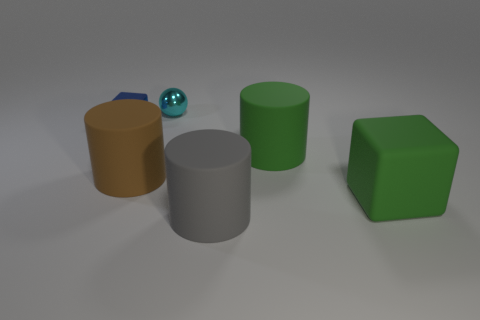Subtract all big green matte cylinders. How many cylinders are left? 2 Add 2 small blue things. How many objects exist? 8 Subtract all green blocks. How many blocks are left? 1 Subtract all blocks. How many objects are left? 4 Subtract 1 balls. How many balls are left? 0 Subtract all tiny objects. Subtract all small purple matte objects. How many objects are left? 4 Add 5 blue shiny objects. How many blue shiny objects are left? 6 Add 4 gray matte cylinders. How many gray matte cylinders exist? 5 Subtract 0 red cubes. How many objects are left? 6 Subtract all yellow blocks. Subtract all gray balls. How many blocks are left? 2 